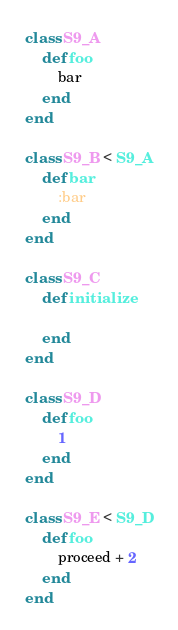<code> <loc_0><loc_0><loc_500><loc_500><_Ruby_>class S9_A
	def foo
		bar
	end
end

class S9_B < S9_A
	def bar
		:bar
	end
end

class S9_C
	def initialize

	end
end

class S9_D
	def foo
		1
	end
end

class S9_E < S9_D
	def foo
		proceed + 2
	end
end</code> 